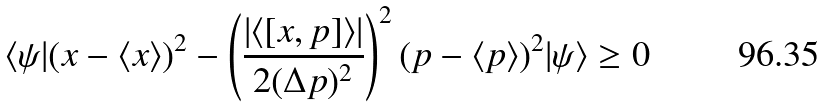Convert formula to latex. <formula><loc_0><loc_0><loc_500><loc_500>\langle \psi | ( { x } - \langle { x } \rangle ) ^ { 2 } - \left ( \frac { | \langle [ { x } , { p } ] \rangle | } { 2 ( \Delta p ) ^ { 2 } } \right ) ^ { 2 } ( { p } - \langle { p } \rangle ) ^ { 2 } | \psi \rangle \geq 0</formula> 